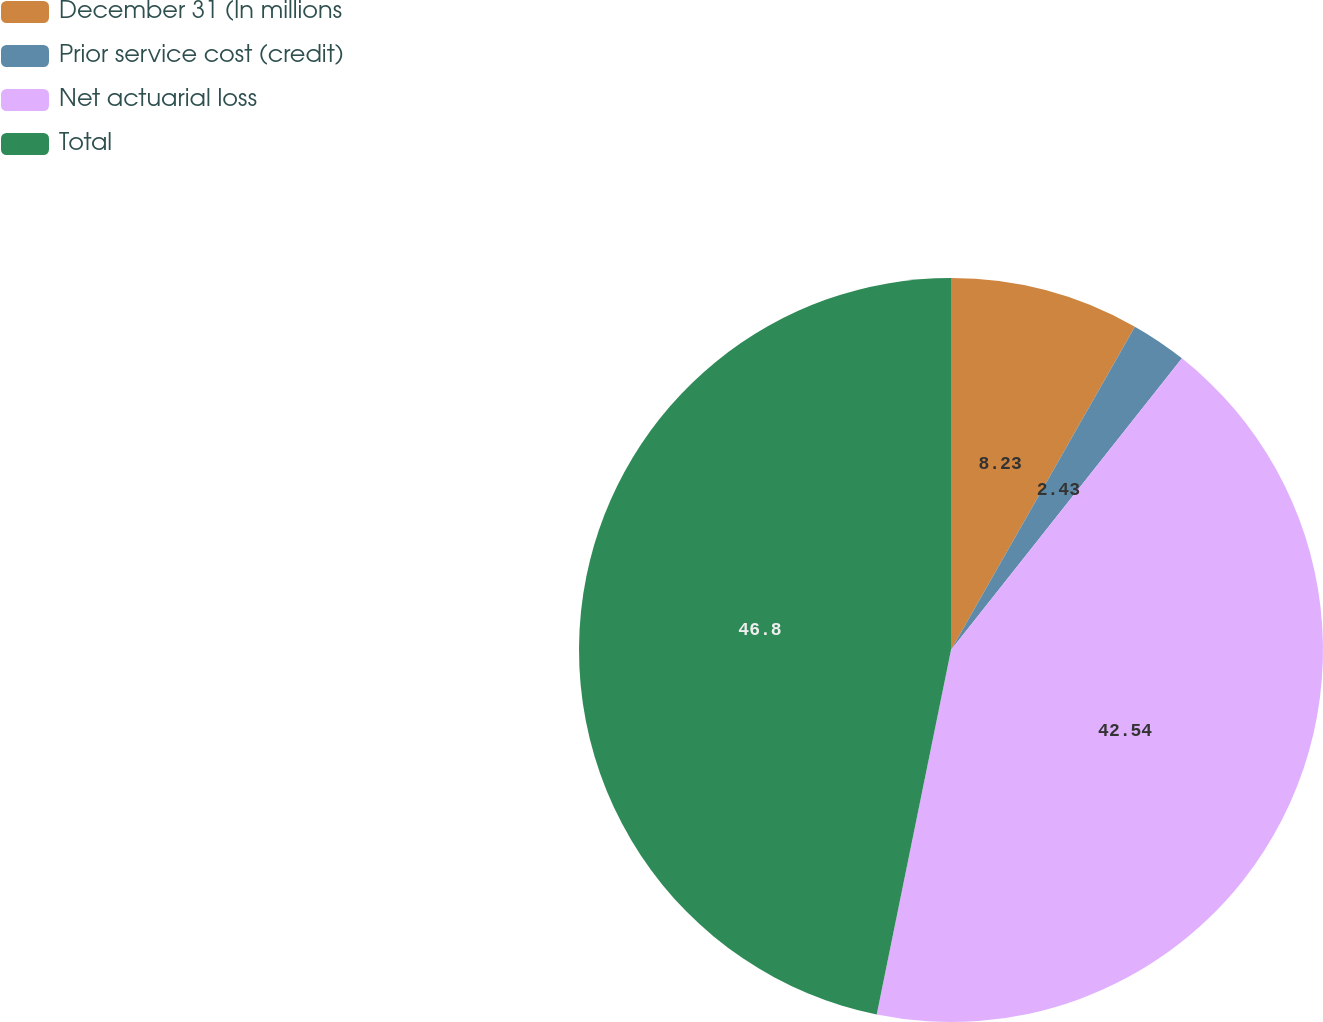<chart> <loc_0><loc_0><loc_500><loc_500><pie_chart><fcel>December 31 (In millions<fcel>Prior service cost (credit)<fcel>Net actuarial loss<fcel>Total<nl><fcel>8.23%<fcel>2.43%<fcel>42.54%<fcel>46.8%<nl></chart> 